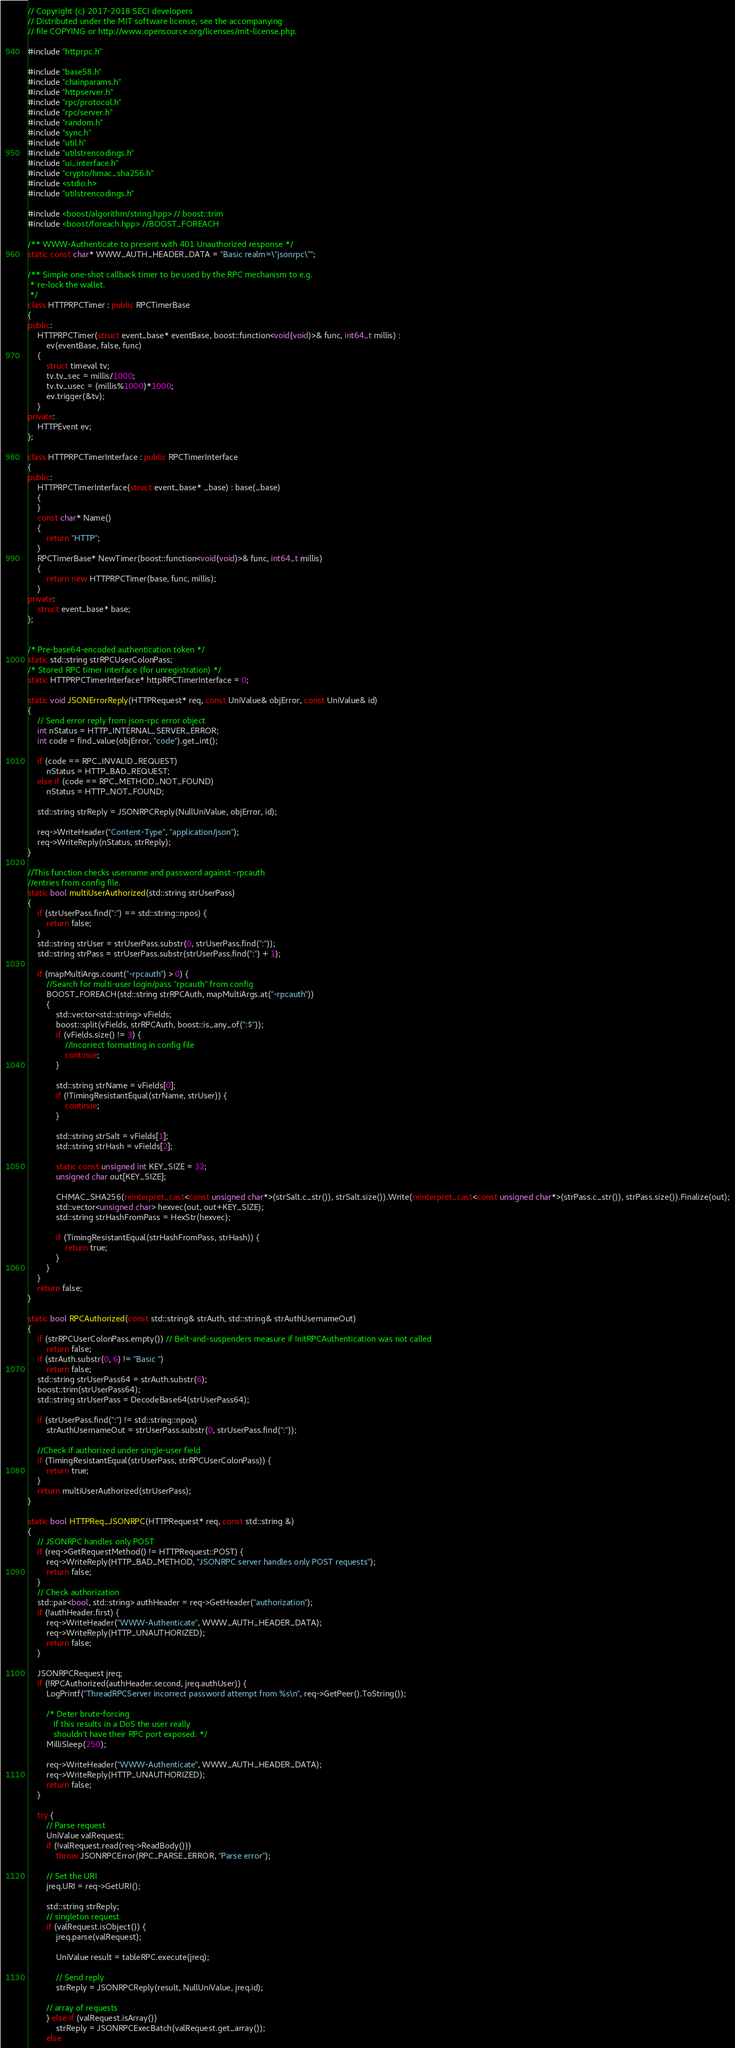Convert code to text. <code><loc_0><loc_0><loc_500><loc_500><_C++_>// Copyright (c) 2017-2018 SECI developers
// Distributed under the MIT software license, see the accompanying
// file COPYING or http://www.opensource.org/licenses/mit-license.php.

#include "httprpc.h"

#include "base58.h"
#include "chainparams.h"
#include "httpserver.h"
#include "rpc/protocol.h"
#include "rpc/server.h"
#include "random.h"
#include "sync.h"
#include "util.h"
#include "utilstrencodings.h"
#include "ui_interface.h"
#include "crypto/hmac_sha256.h"
#include <stdio.h>
#include "utilstrencodings.h"

#include <boost/algorithm/string.hpp> // boost::trim
#include <boost/foreach.hpp> //BOOST_FOREACH

/** WWW-Authenticate to present with 401 Unauthorized response */
static const char* WWW_AUTH_HEADER_DATA = "Basic realm=\"jsonrpc\"";

/** Simple one-shot callback timer to be used by the RPC mechanism to e.g.
 * re-lock the wallet.
 */
class HTTPRPCTimer : public RPCTimerBase
{
public:
    HTTPRPCTimer(struct event_base* eventBase, boost::function<void(void)>& func, int64_t millis) :
        ev(eventBase, false, func)
    {
        struct timeval tv;
        tv.tv_sec = millis/1000;
        tv.tv_usec = (millis%1000)*1000;
        ev.trigger(&tv);
    }
private:
    HTTPEvent ev;
};

class HTTPRPCTimerInterface : public RPCTimerInterface
{
public:
    HTTPRPCTimerInterface(struct event_base* _base) : base(_base)
    {
    }
    const char* Name()
    {
        return "HTTP";
    }
    RPCTimerBase* NewTimer(boost::function<void(void)>& func, int64_t millis)
    {
        return new HTTPRPCTimer(base, func, millis);
    }
private:
    struct event_base* base;
};


/* Pre-base64-encoded authentication token */
static std::string strRPCUserColonPass;
/* Stored RPC timer interface (for unregistration) */
static HTTPRPCTimerInterface* httpRPCTimerInterface = 0;

static void JSONErrorReply(HTTPRequest* req, const UniValue& objError, const UniValue& id)
{
    // Send error reply from json-rpc error object
    int nStatus = HTTP_INTERNAL_SERVER_ERROR;
    int code = find_value(objError, "code").get_int();

    if (code == RPC_INVALID_REQUEST)
        nStatus = HTTP_BAD_REQUEST;
    else if (code == RPC_METHOD_NOT_FOUND)
        nStatus = HTTP_NOT_FOUND;

    std::string strReply = JSONRPCReply(NullUniValue, objError, id);

    req->WriteHeader("Content-Type", "application/json");
    req->WriteReply(nStatus, strReply);
}

//This function checks username and password against -rpcauth
//entries from config file.
static bool multiUserAuthorized(std::string strUserPass)
{    
    if (strUserPass.find(":") == std::string::npos) {
        return false;
    }
    std::string strUser = strUserPass.substr(0, strUserPass.find(":"));
    std::string strPass = strUserPass.substr(strUserPass.find(":") + 1);

    if (mapMultiArgs.count("-rpcauth") > 0) {
        //Search for multi-user login/pass "rpcauth" from config
        BOOST_FOREACH(std::string strRPCAuth, mapMultiArgs.at("-rpcauth"))
        {
            std::vector<std::string> vFields;
            boost::split(vFields, strRPCAuth, boost::is_any_of(":$"));
            if (vFields.size() != 3) {
                //Incorrect formatting in config file
                continue;
            }

            std::string strName = vFields[0];
            if (!TimingResistantEqual(strName, strUser)) {
                continue;
            }

            std::string strSalt = vFields[1];
            std::string strHash = vFields[2];

            static const unsigned int KEY_SIZE = 32;
            unsigned char out[KEY_SIZE];

            CHMAC_SHA256(reinterpret_cast<const unsigned char*>(strSalt.c_str()), strSalt.size()).Write(reinterpret_cast<const unsigned char*>(strPass.c_str()), strPass.size()).Finalize(out);
            std::vector<unsigned char> hexvec(out, out+KEY_SIZE);
            std::string strHashFromPass = HexStr(hexvec);

            if (TimingResistantEqual(strHashFromPass, strHash)) {
                return true;
            }
        }
    }
    return false;
}

static bool RPCAuthorized(const std::string& strAuth, std::string& strAuthUsernameOut)
{
    if (strRPCUserColonPass.empty()) // Belt-and-suspenders measure if InitRPCAuthentication was not called
        return false;
    if (strAuth.substr(0, 6) != "Basic ")
        return false;
    std::string strUserPass64 = strAuth.substr(6);
    boost::trim(strUserPass64);
    std::string strUserPass = DecodeBase64(strUserPass64);

    if (strUserPass.find(":") != std::string::npos)
        strAuthUsernameOut = strUserPass.substr(0, strUserPass.find(":"));

    //Check if authorized under single-user field
    if (TimingResistantEqual(strUserPass, strRPCUserColonPass)) {
        return true;
    }
    return multiUserAuthorized(strUserPass);
}

static bool HTTPReq_JSONRPC(HTTPRequest* req, const std::string &)
{
    // JSONRPC handles only POST
    if (req->GetRequestMethod() != HTTPRequest::POST) {
        req->WriteReply(HTTP_BAD_METHOD, "JSONRPC server handles only POST requests");
        return false;
    }
    // Check authorization
    std::pair<bool, std::string> authHeader = req->GetHeader("authorization");
    if (!authHeader.first) {
        req->WriteHeader("WWW-Authenticate", WWW_AUTH_HEADER_DATA);
        req->WriteReply(HTTP_UNAUTHORIZED);
        return false;
    }

    JSONRPCRequest jreq;
    if (!RPCAuthorized(authHeader.second, jreq.authUser)) {
        LogPrintf("ThreadRPCServer incorrect password attempt from %s\n", req->GetPeer().ToString());

        /* Deter brute-forcing
           If this results in a DoS the user really
           shouldn't have their RPC port exposed. */
        MilliSleep(250);

        req->WriteHeader("WWW-Authenticate", WWW_AUTH_HEADER_DATA);
        req->WriteReply(HTTP_UNAUTHORIZED);
        return false;
    }

    try {
        // Parse request
        UniValue valRequest;
        if (!valRequest.read(req->ReadBody()))
            throw JSONRPCError(RPC_PARSE_ERROR, "Parse error");

        // Set the URI
        jreq.URI = req->GetURI();

        std::string strReply;
        // singleton request
        if (valRequest.isObject()) {
            jreq.parse(valRequest);

            UniValue result = tableRPC.execute(jreq);

            // Send reply
            strReply = JSONRPCReply(result, NullUniValue, jreq.id);

        // array of requests
        } else if (valRequest.isArray())
            strReply = JSONRPCExecBatch(valRequest.get_array());
        else</code> 